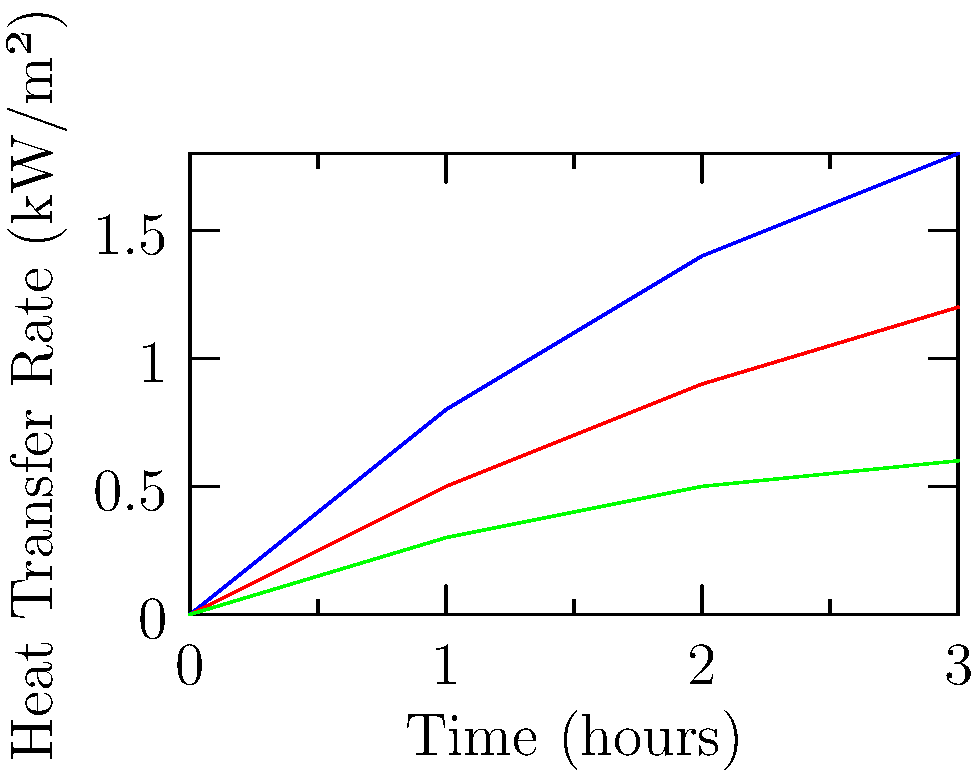Based on the heat transfer rate graphs for three different materials in a heat exchanger, which material would be most efficient for rapid heat transfer in the first hour of operation? To determine the most efficient material for rapid heat transfer in the first hour, we need to analyze the heat transfer rates for each material:

1. Interpret the graph:
   - The x-axis represents time in hours
   - The y-axis represents the heat transfer rate in kW/m²
   - Three lines represent Materials A (blue), B (red), and C (green)

2. Compare the heat transfer rates at t = 1 hour:
   - Material A: ~0.8 kW/m²
   - Material B: ~0.5 kW/m²
   - Material C: ~0.3 kW/m²

3. Analyze the slopes of the lines in the first hour:
   - Material A has the steepest slope
   - Material B has a moderate slope
   - Material C has the gentlest slope

4. Consider the definition of efficiency in this context:
   - Higher heat transfer rate indicates greater efficiency
   - Steeper slope indicates faster increase in heat transfer rate

5. Conclusion:
   Material A has both the highest heat transfer rate at t = 1 hour and the steepest slope in the first hour, indicating it would be the most efficient for rapid heat transfer in the first hour of operation.
Answer: Material A 